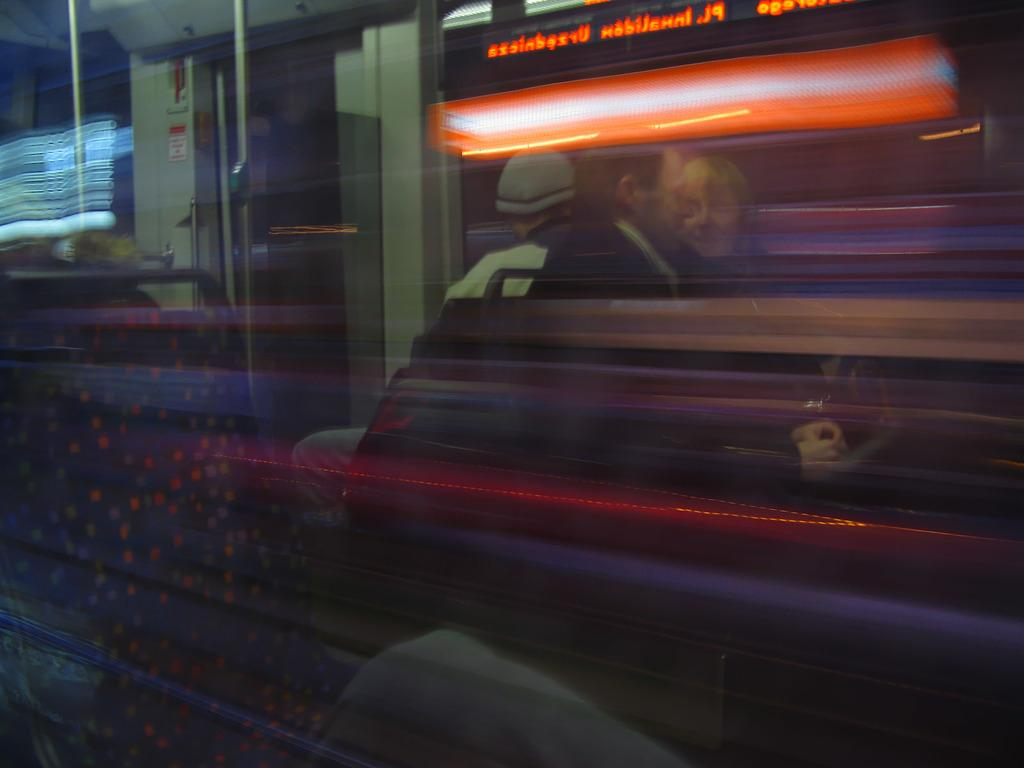What is the main subject of the image? The main subject of the image is a train. What are the people in the image doing? People are standing in the train. What else can be seen in the image besides the train and people? There are lights visible in the image. How many cows are visible in the image? There are no cows present in the image; it features a train with people standing inside. What type of quilt is being used to cover the train in the image? There is no quilt present in the image; it is a train with people standing inside and lights visible. 